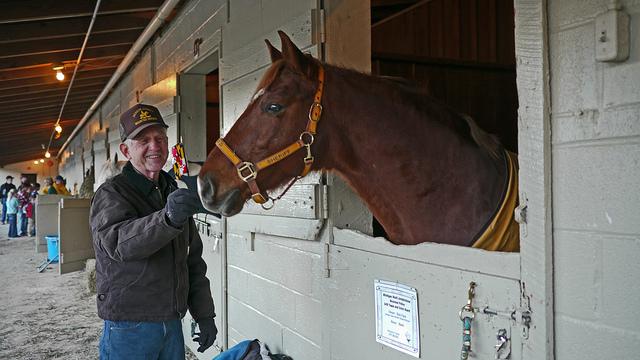Does this man like horses?
Keep it brief. Yes. What color is the horse's mane?
Concise answer only. Brown. What colors is the wall painted?
Answer briefly. White. Is this horse locked in a stable?
Quick response, please. Yes. What is the small white box at the top right corner?
Short answer required. Light switch. 